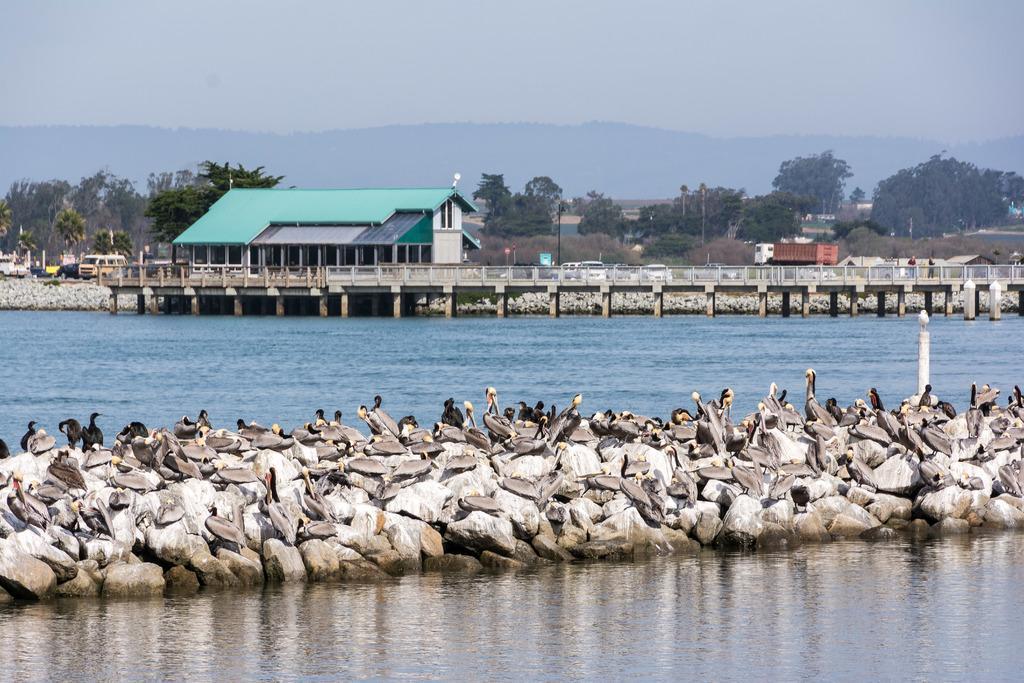Describe this image in one or two sentences. In this image there are so many birds on the stones at the middle of water, beside that there are there is a bridge and building and also there are some vehicles riding on the road, behind the road there are so many trees and mountains. 